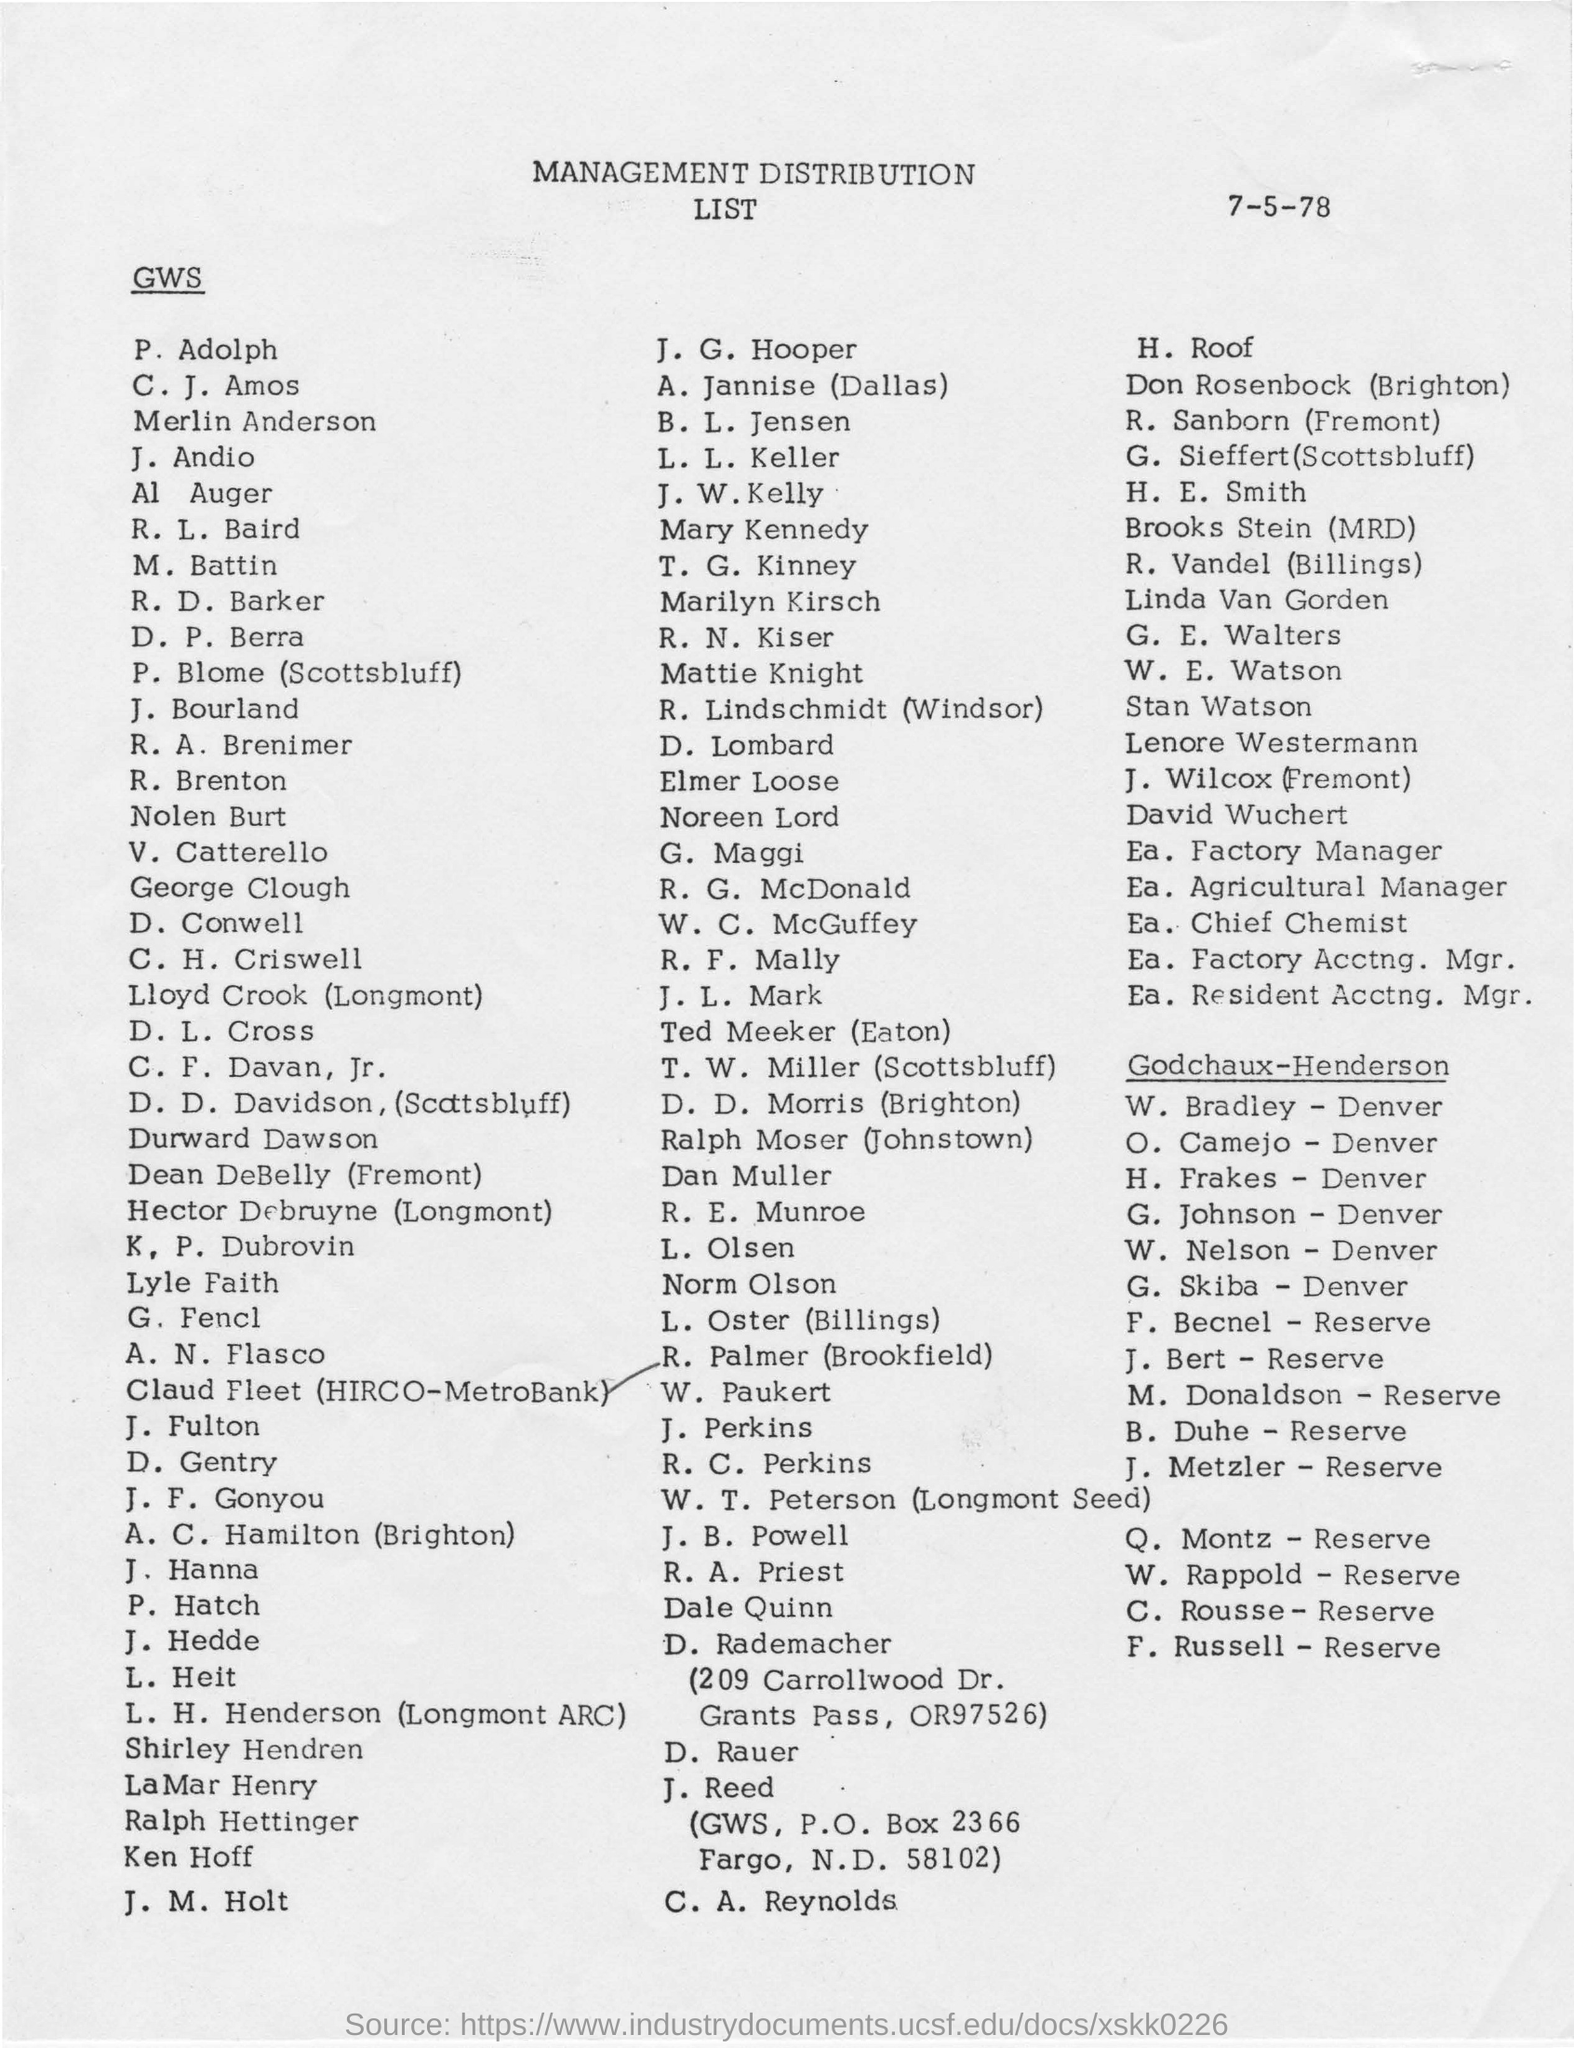What is the date mentioned in the given page ?
Your answer should be compact. 7-5-78. 